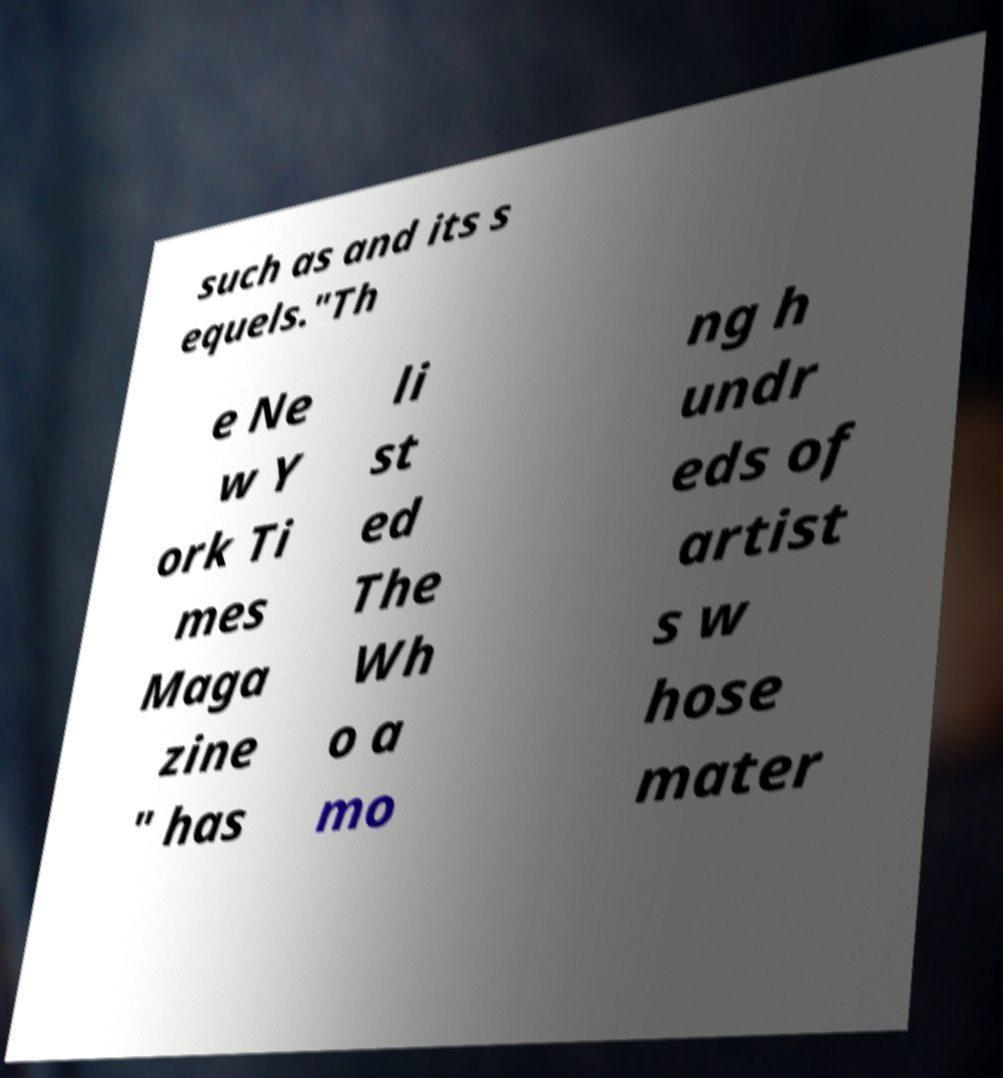Please identify and transcribe the text found in this image. such as and its s equels."Th e Ne w Y ork Ti mes Maga zine " has li st ed The Wh o a mo ng h undr eds of artist s w hose mater 